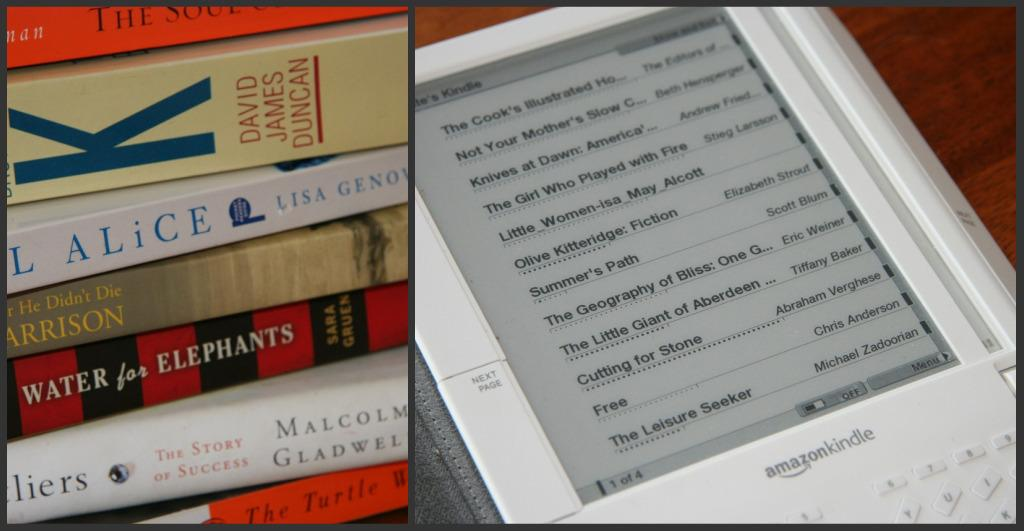Provide a one-sentence caption for the provided image. A stack of books next to an Amazon Kindle. 